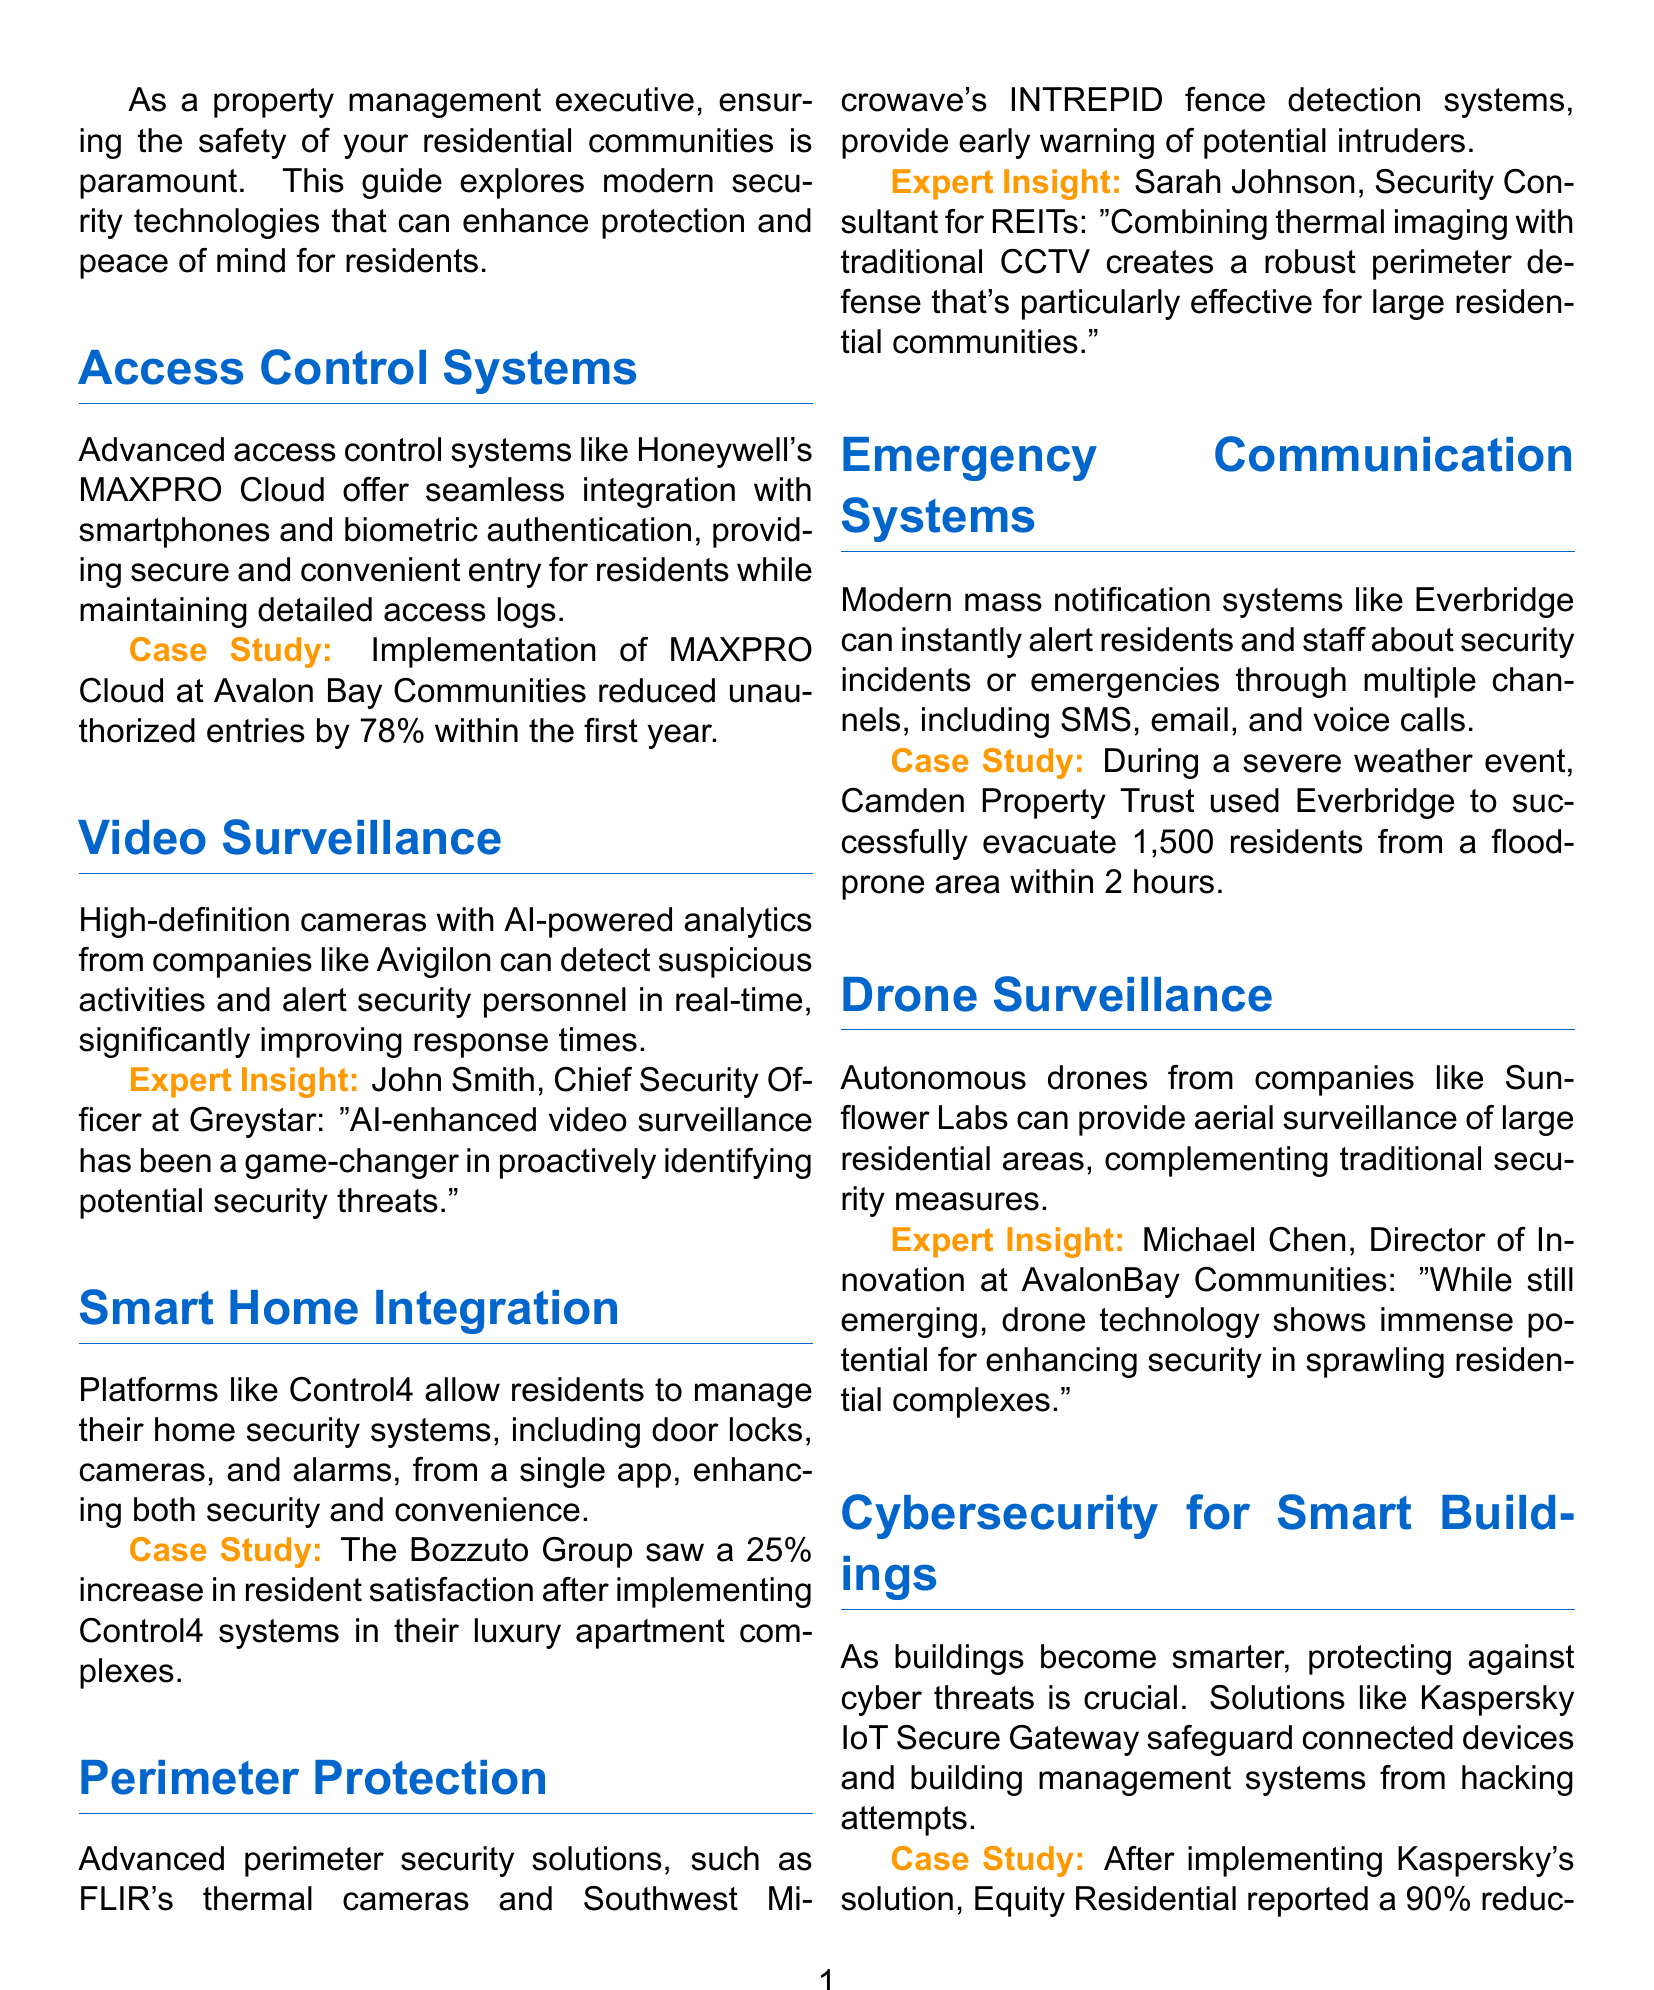What is the main focus of the guide? The main focus of the guide is on modern security technologies for enhancing safety in residential communities.
Answer: modern security technologies for enhancing safety in residential communities What access control system is mentioned? The access control system highlighted in the document is Honeywell's MAXPRO Cloud.
Answer: Honeywell's MAXPRO Cloud By what percentage did unauthorized entries reduce with MAXPRO Cloud? The document states that unauthorized entries were reduced by 78% within the first year of implementation.
Answer: 78% Who provided an expert insight on video surveillance? The expert insight on video surveillance was provided by John Smith.
Answer: John Smith What was the percentage increase in resident satisfaction after implementing Control4 systems? The Bozzuto Group saw a 25% increase in resident satisfaction after implementing Control4 systems.
Answer: 25% What technology was combined with traditional CCTV for perimeter protection? The document mentions that thermal imaging was combined with traditional CCTV for perimeter protection.
Answer: thermal imaging How many residents did Camden Property Trust evacuate during a flood event? During the flood event, Camden Property Trust successfully evacuated 1,500 residents.
Answer: 1,500 What did Equity Residential report after implementing Kaspersky's solution? After implementing Kaspersky's solution, Equity Residential reported a 90% reduction in cybersecurity incidents.
Answer: 90% What is one benefit of drone surveillance mentioned? The document states that drone technology shows immense potential for enhancing security in sprawling residential complexes.
Answer: immense potential for enhancing security What is the overall conclusion of the guide? The conclusion emphasizes that investing in these technologies enhances safety and adds value to properties.
Answer: enhances safety and adds value to properties 